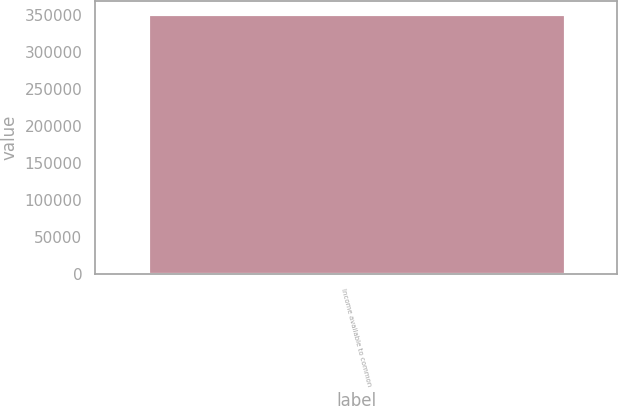<chart> <loc_0><loc_0><loc_500><loc_500><bar_chart><fcel>Income available to common<nl><fcel>350908<nl></chart> 